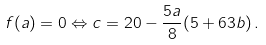Convert formula to latex. <formula><loc_0><loc_0><loc_500><loc_500>f ( a ) = 0 \Leftrightarrow c = 2 0 - \frac { 5 a } { 8 } ( 5 + 6 3 b ) \, .</formula> 